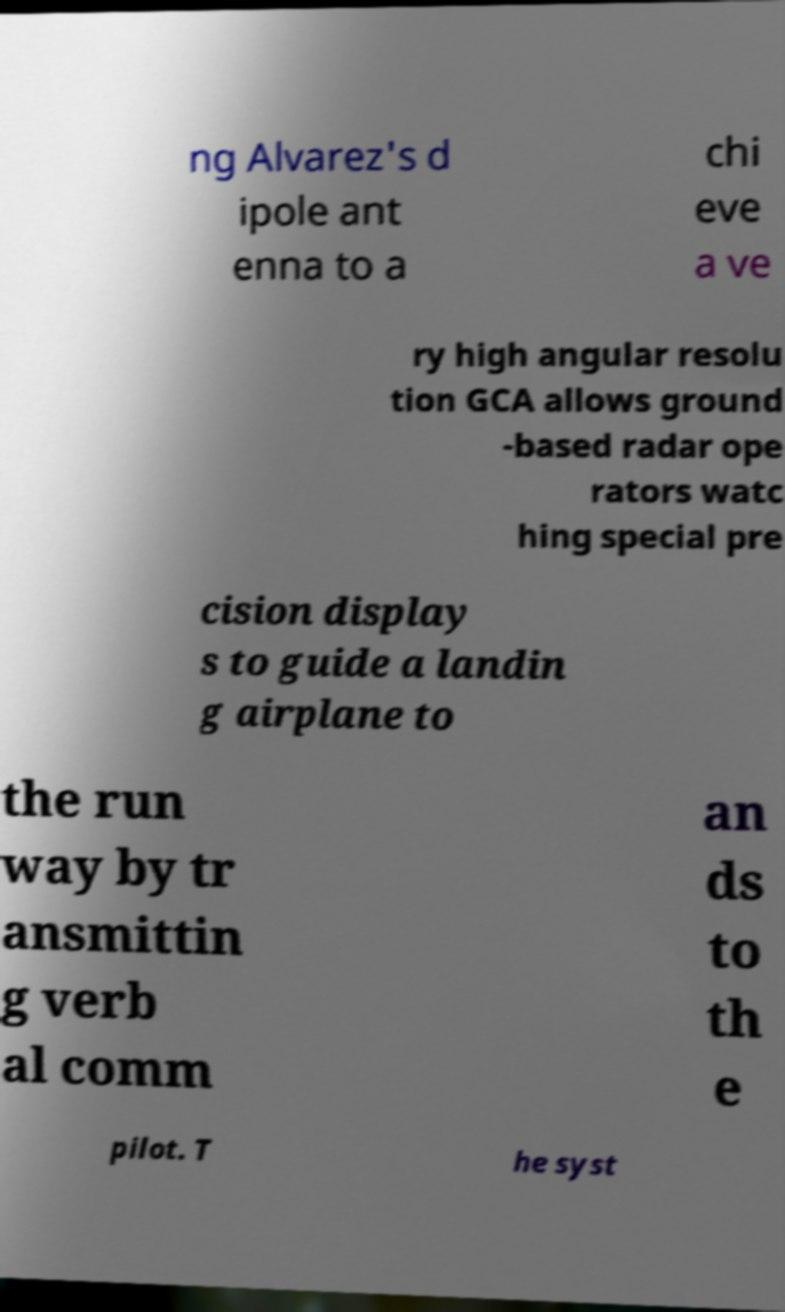Could you assist in decoding the text presented in this image and type it out clearly? ng Alvarez's d ipole ant enna to a chi eve a ve ry high angular resolu tion GCA allows ground -based radar ope rators watc hing special pre cision display s to guide a landin g airplane to the run way by tr ansmittin g verb al comm an ds to th e pilot. T he syst 